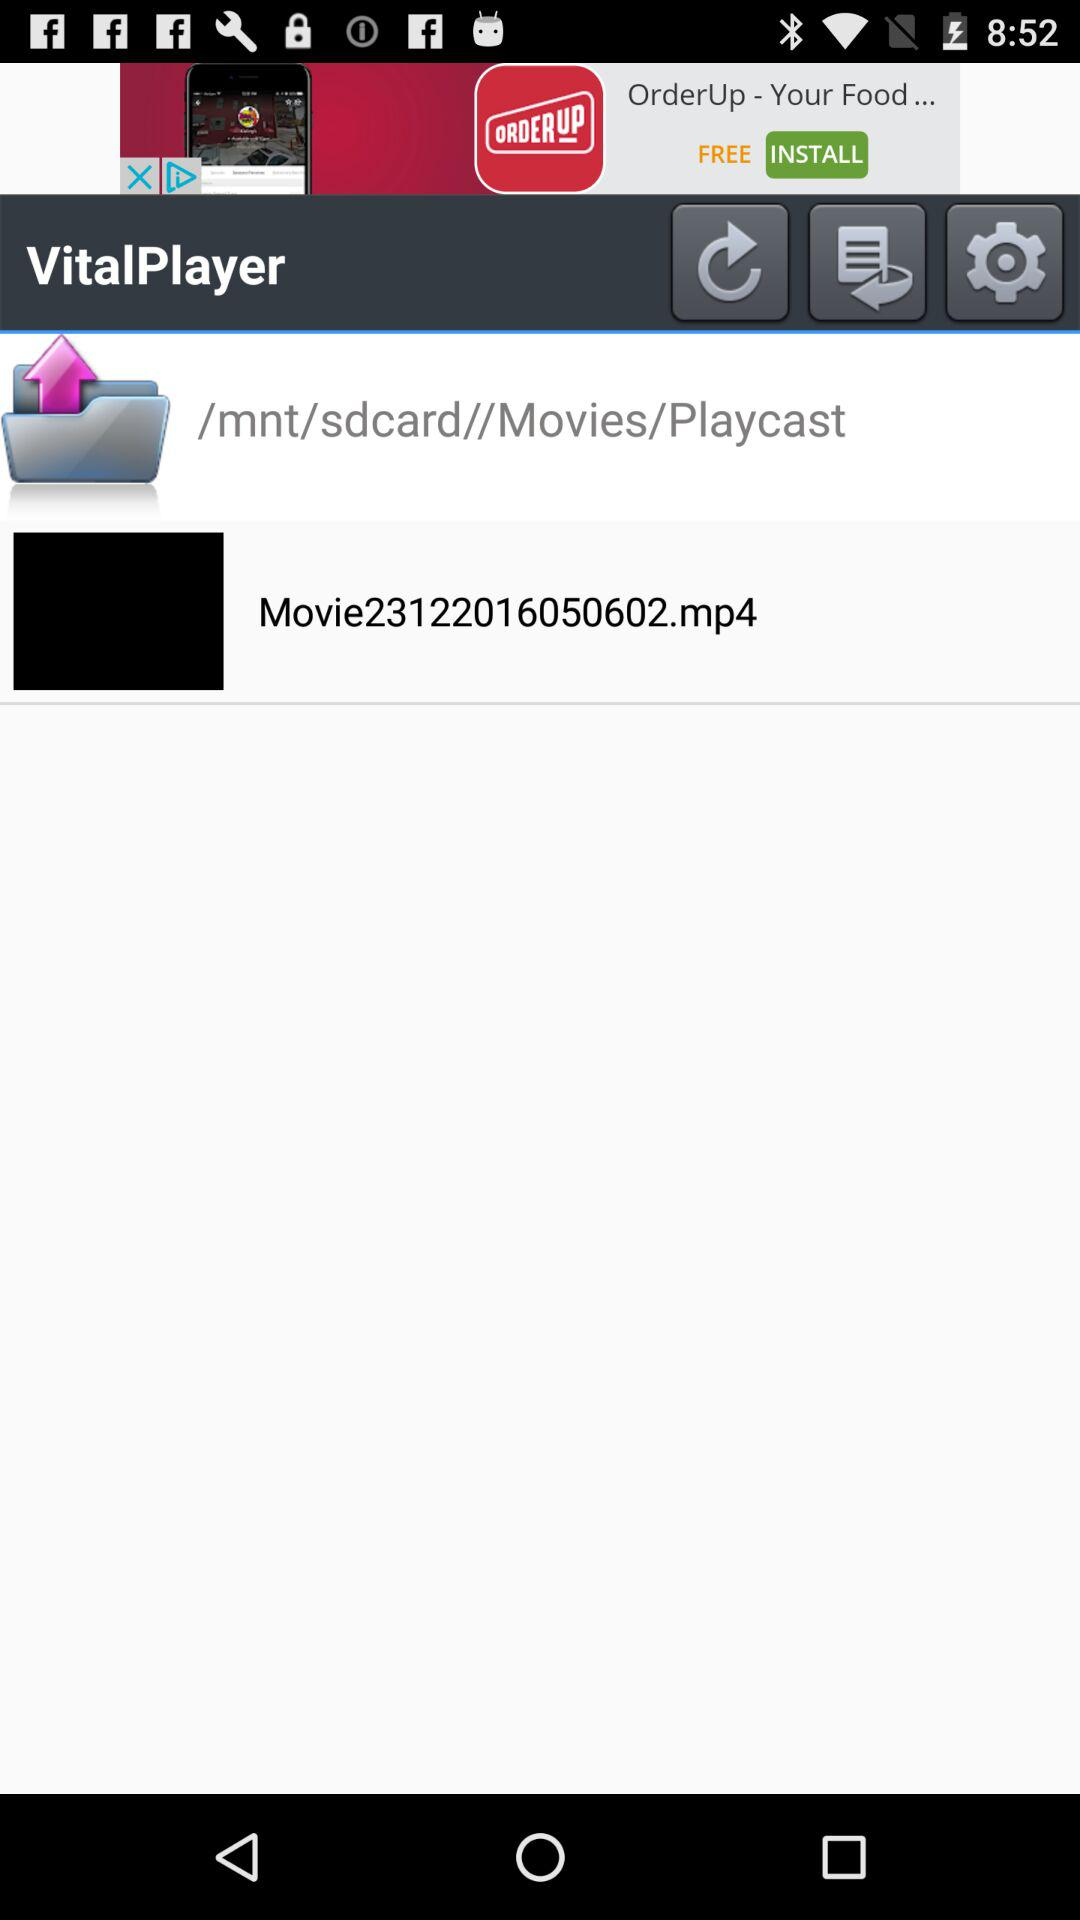What is the name of the movie? The name of the movie is Movie23122016050602.mp4. 